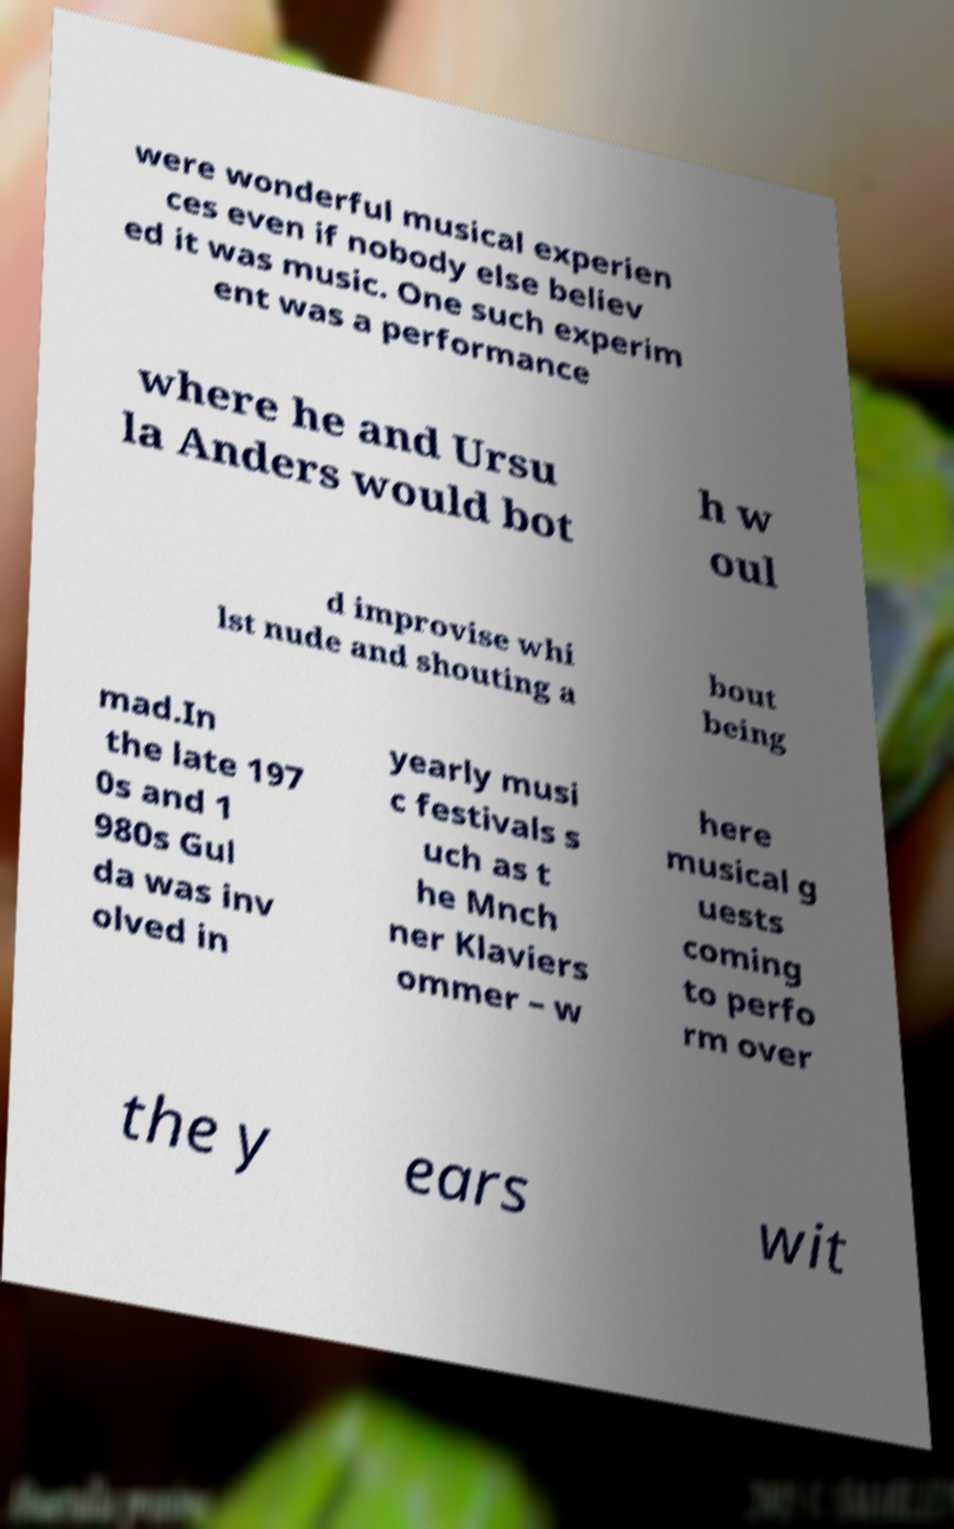Please identify and transcribe the text found in this image. were wonderful musical experien ces even if nobody else believ ed it was music. One such experim ent was a performance where he and Ursu la Anders would bot h w oul d improvise whi lst nude and shouting a bout being mad.In the late 197 0s and 1 980s Gul da was inv olved in yearly musi c festivals s uch as t he Mnch ner Klaviers ommer – w here musical g uests coming to perfo rm over the y ears wit 